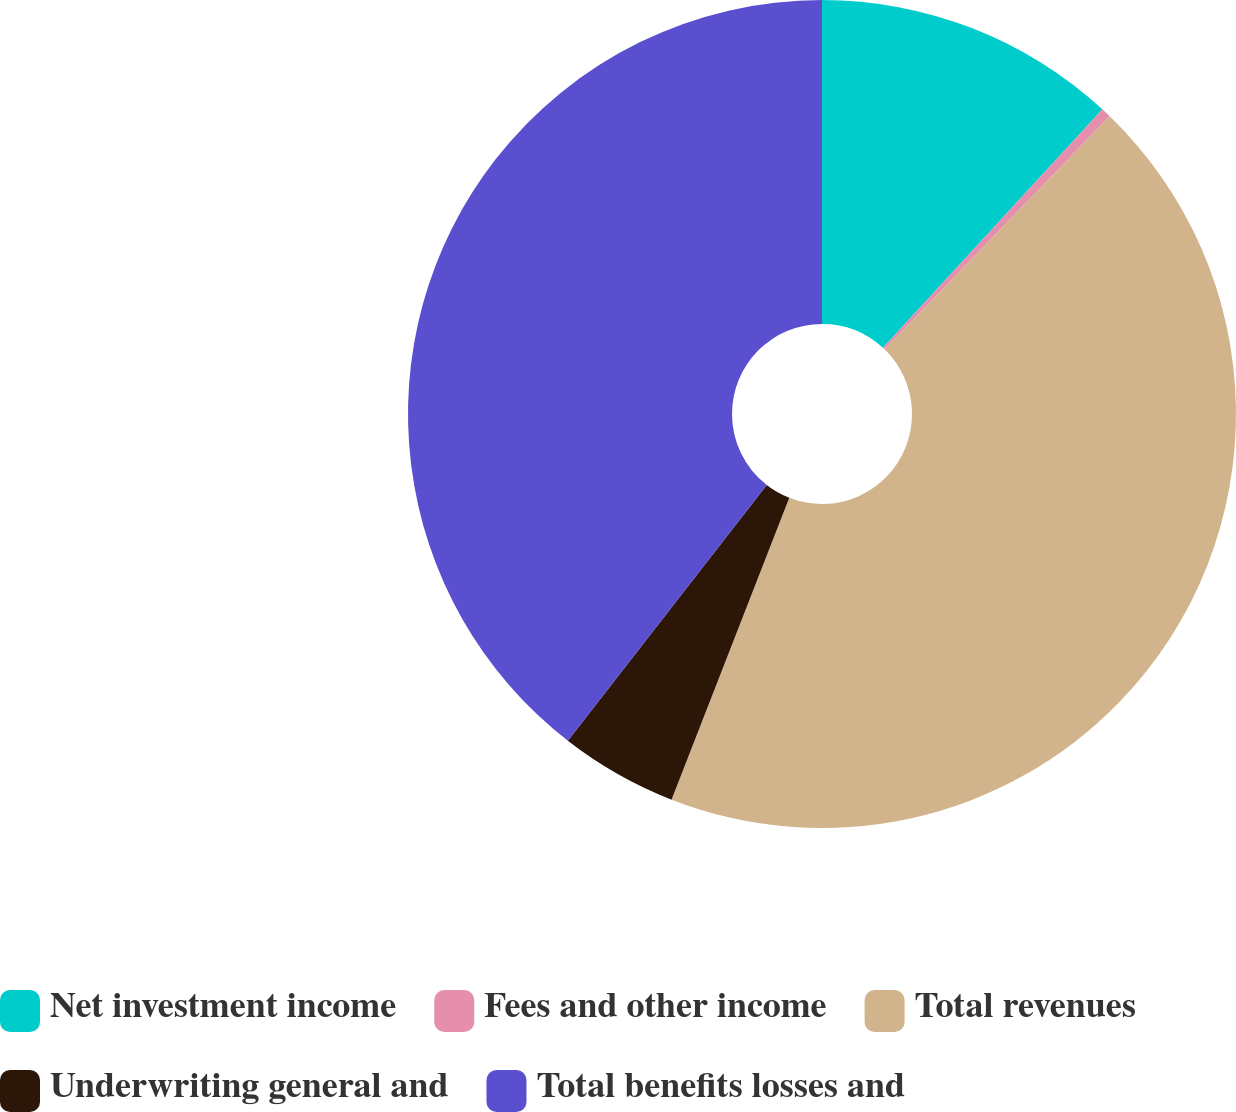Convert chart. <chart><loc_0><loc_0><loc_500><loc_500><pie_chart><fcel>Net investment income<fcel>Fees and other income<fcel>Total revenues<fcel>Underwriting general and<fcel>Total benefits losses and<nl><fcel>11.84%<fcel>0.39%<fcel>43.69%<fcel>4.6%<fcel>39.48%<nl></chart> 